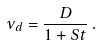<formula> <loc_0><loc_0><loc_500><loc_500>\nu _ { d } = \frac { D } { 1 + S t } \, .</formula> 